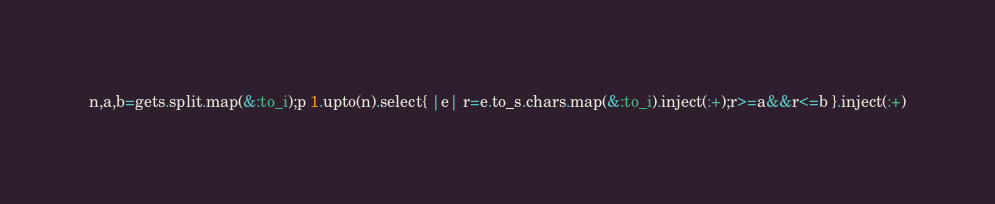Convert code to text. <code><loc_0><loc_0><loc_500><loc_500><_Ruby_>n,a,b=gets.split.map(&:to_i);p 1.upto(n).select{ |e| r=e.to_s.chars.map(&:to_i).inject(:+);r>=a&&r<=b }.inject(:+)
</code> 